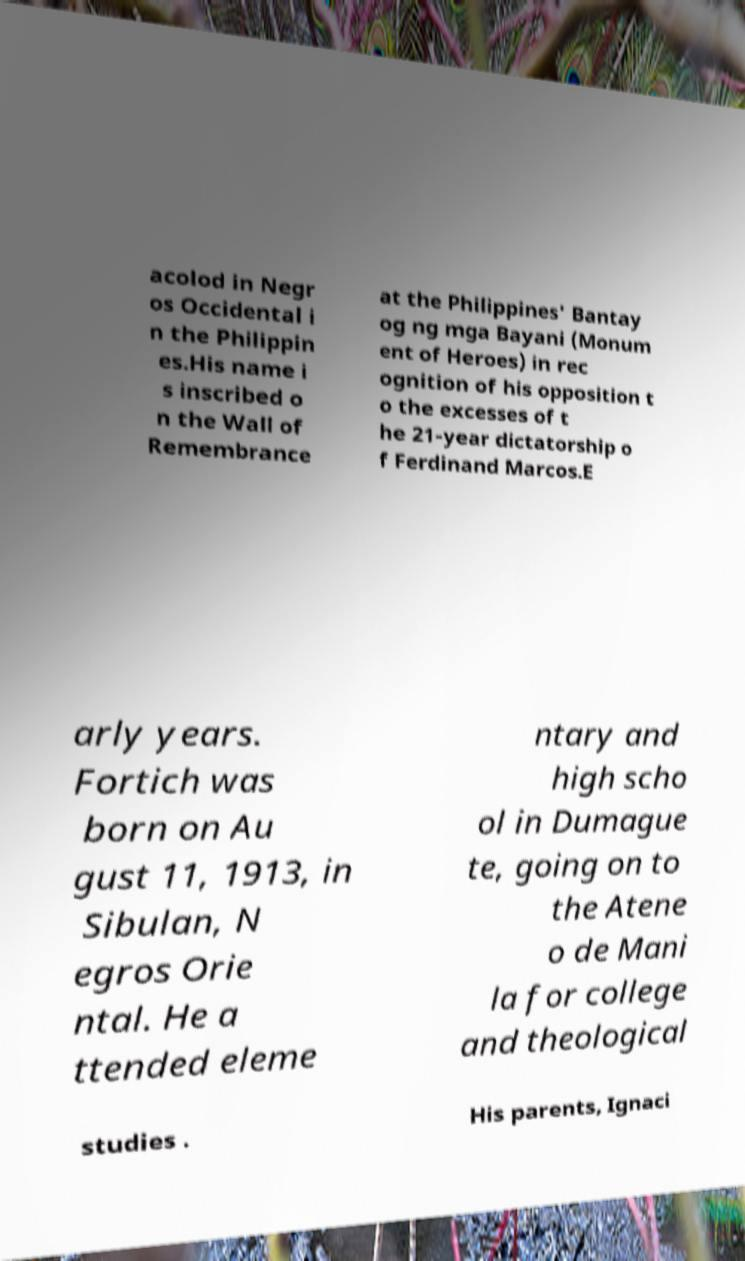There's text embedded in this image that I need extracted. Can you transcribe it verbatim? acolod in Negr os Occidental i n the Philippin es.His name i s inscribed o n the Wall of Remembrance at the Philippines' Bantay og ng mga Bayani (Monum ent of Heroes) in rec ognition of his opposition t o the excesses of t he 21-year dictatorship o f Ferdinand Marcos.E arly years. Fortich was born on Au gust 11, 1913, in Sibulan, N egros Orie ntal. He a ttended eleme ntary and high scho ol in Dumague te, going on to the Atene o de Mani la for college and theological studies . His parents, Ignaci 